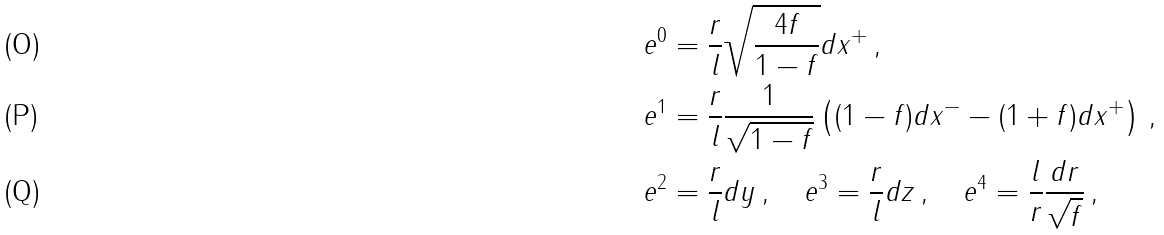Convert formula to latex. <formula><loc_0><loc_0><loc_500><loc_500>e ^ { 0 } & = \frac { r } { l } \sqrt { \frac { 4 f } { 1 - f } } d x ^ { + } \, , \\ e ^ { 1 } & = \frac { r } { l } \frac { 1 } { \sqrt { 1 - f } } \left ( ( 1 - f ) d x ^ { - } - ( 1 + f ) d x ^ { + } \right ) \, , \\ e ^ { 2 } & = \frac { r } { l } d y \, , \quad e ^ { 3 } = \frac { r } { l } d z \, , \quad e ^ { 4 } = \frac { l } { r } \frac { d r } { \sqrt { f } } \, ,</formula> 